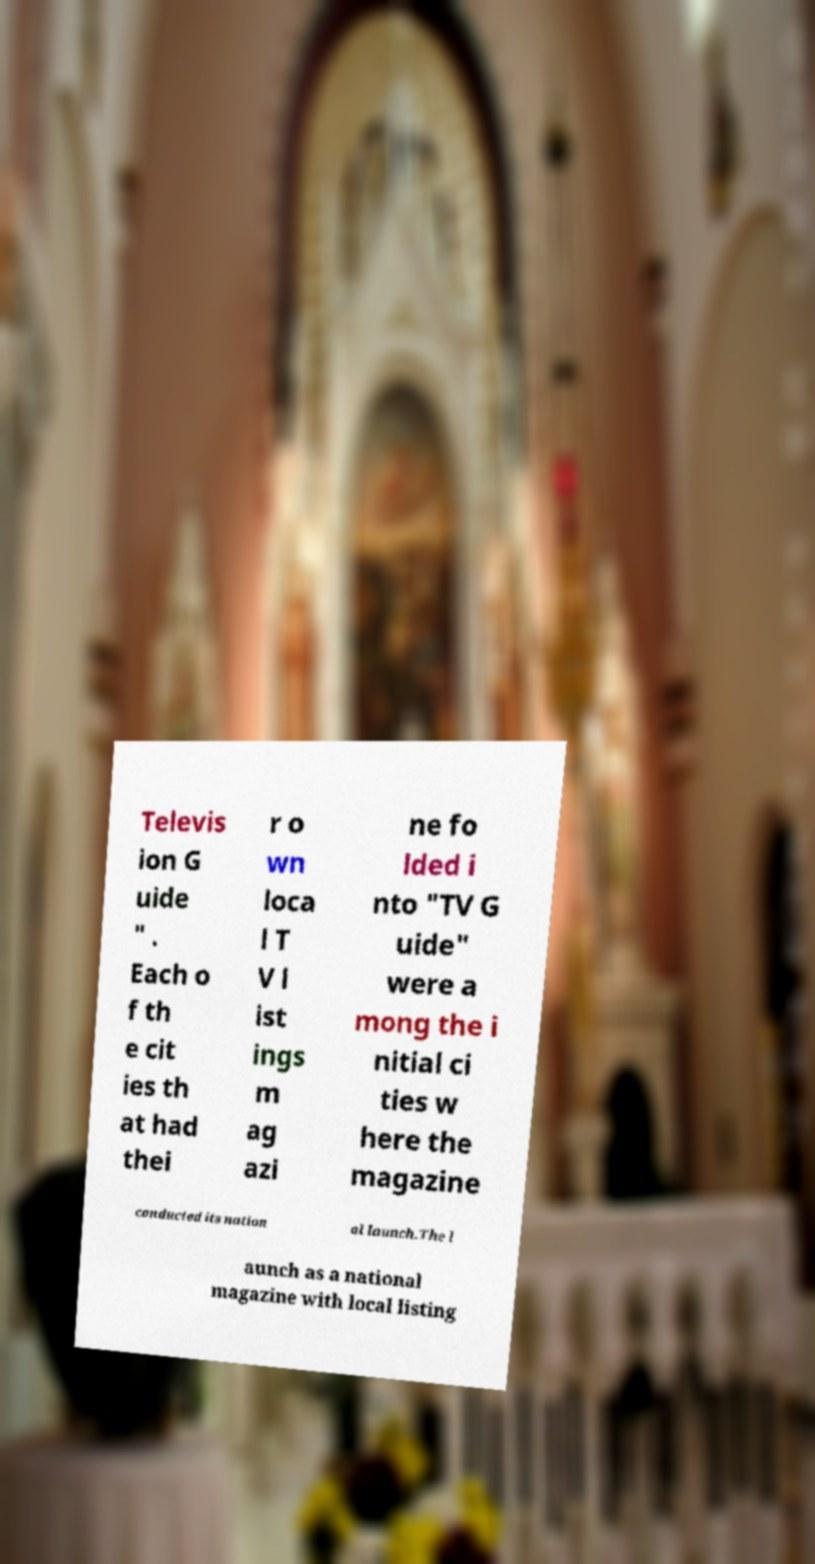Can you read and provide the text displayed in the image?This photo seems to have some interesting text. Can you extract and type it out for me? Televis ion G uide " . Each o f th e cit ies th at had thei r o wn loca l T V l ist ings m ag azi ne fo lded i nto "TV G uide" were a mong the i nitial ci ties w here the magazine conducted its nation al launch.The l aunch as a national magazine with local listing 